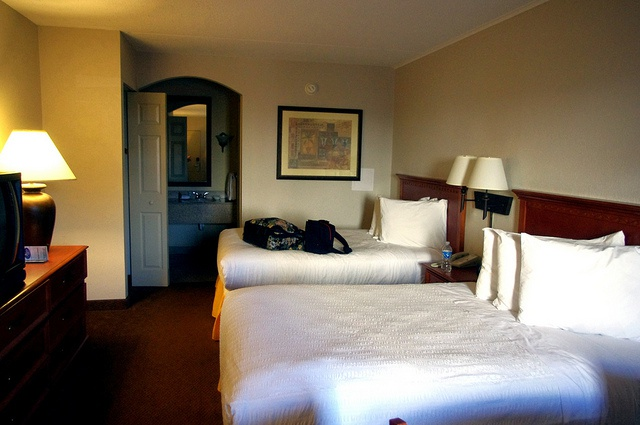Describe the objects in this image and their specific colors. I can see bed in olive, white, darkgray, and lightgray tones, bed in olive, beige, darkgray, maroon, and black tones, tv in olive, black, maroon, brown, and orange tones, handbag in olive, black, and gray tones, and handbag in olive, black, gray, and maroon tones in this image. 